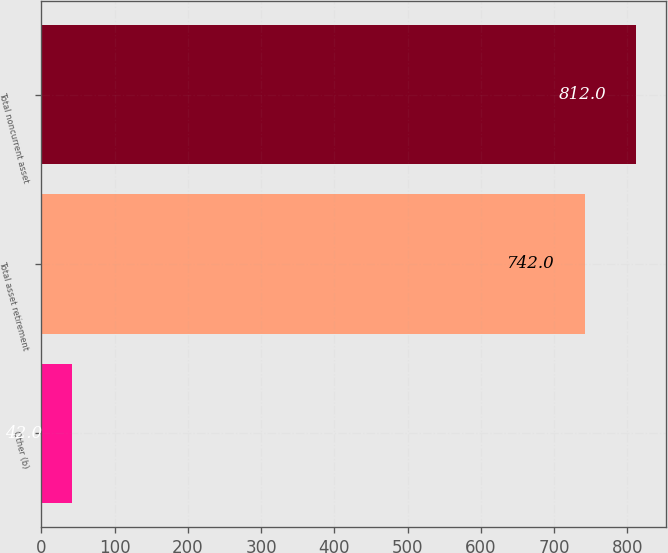Convert chart to OTSL. <chart><loc_0><loc_0><loc_500><loc_500><bar_chart><fcel>Other (b)<fcel>Total asset retirement<fcel>Total noncurrent asset<nl><fcel>42<fcel>742<fcel>812<nl></chart> 